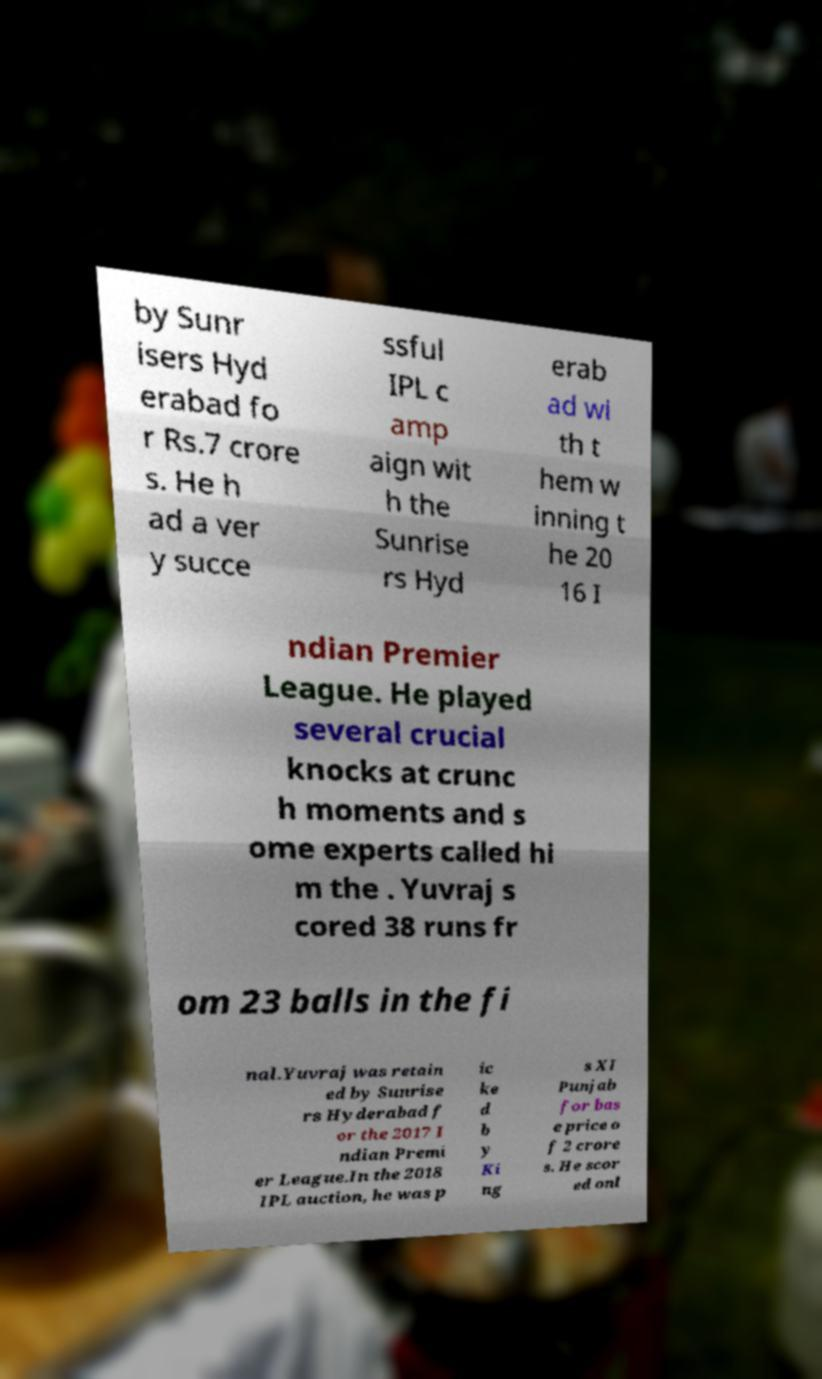Could you assist in decoding the text presented in this image and type it out clearly? by Sunr isers Hyd erabad fo r Rs.7 crore s. He h ad a ver y succe ssful IPL c amp aign wit h the Sunrise rs Hyd erab ad wi th t hem w inning t he 20 16 I ndian Premier League. He played several crucial knocks at crunc h moments and s ome experts called hi m the . Yuvraj s cored 38 runs fr om 23 balls in the fi nal.Yuvraj was retain ed by Sunrise rs Hyderabad f or the 2017 I ndian Premi er League.In the 2018 IPL auction, he was p ic ke d b y Ki ng s XI Punjab for bas e price o f 2 crore s. He scor ed onl 